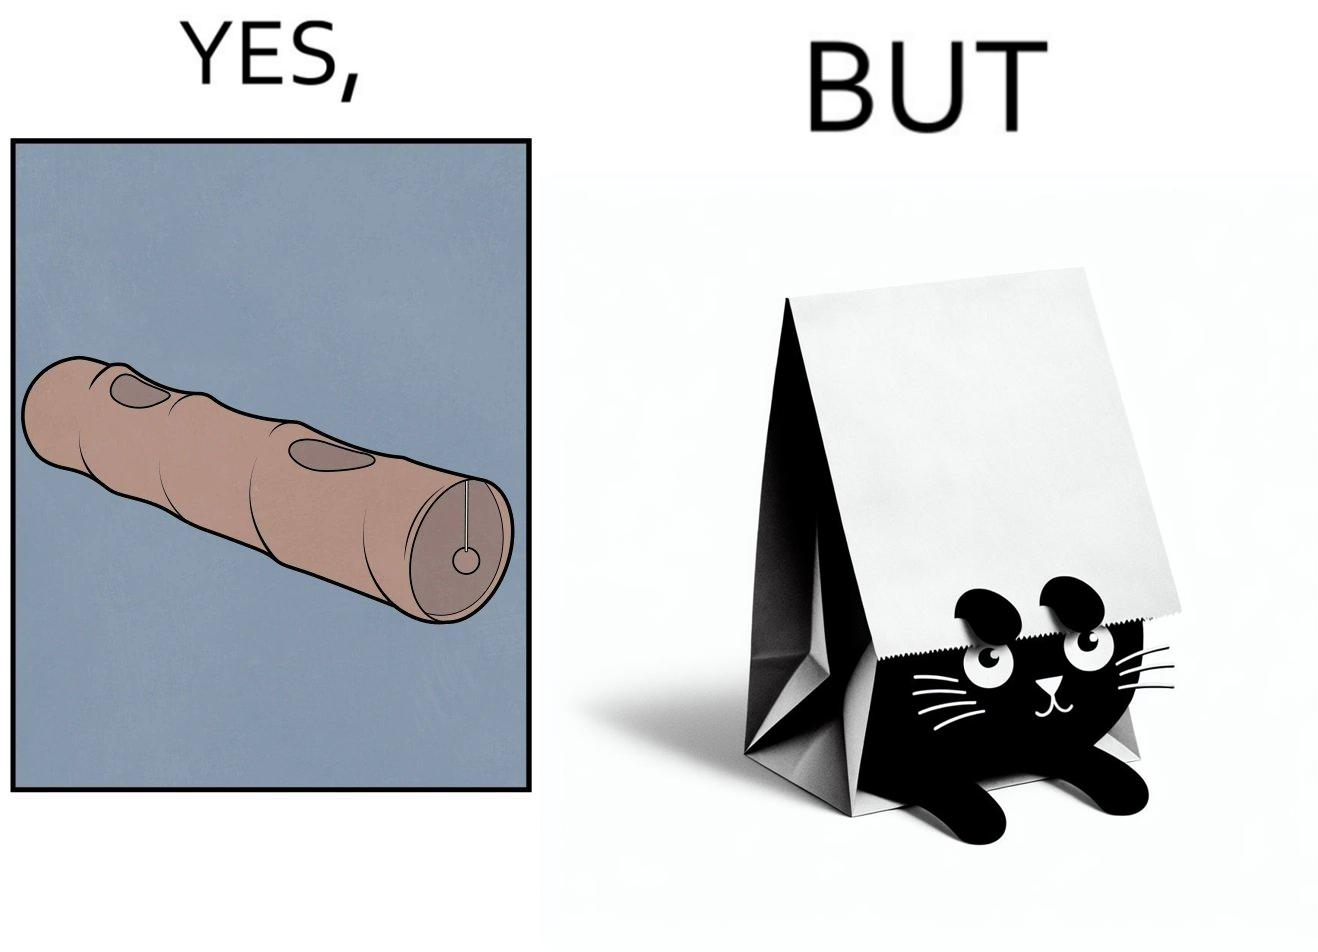Explain the humor or irony in this image. The image is funny, because even when there is a dedicated thing for the animal to play with it still is hiding itself in the paper bag 